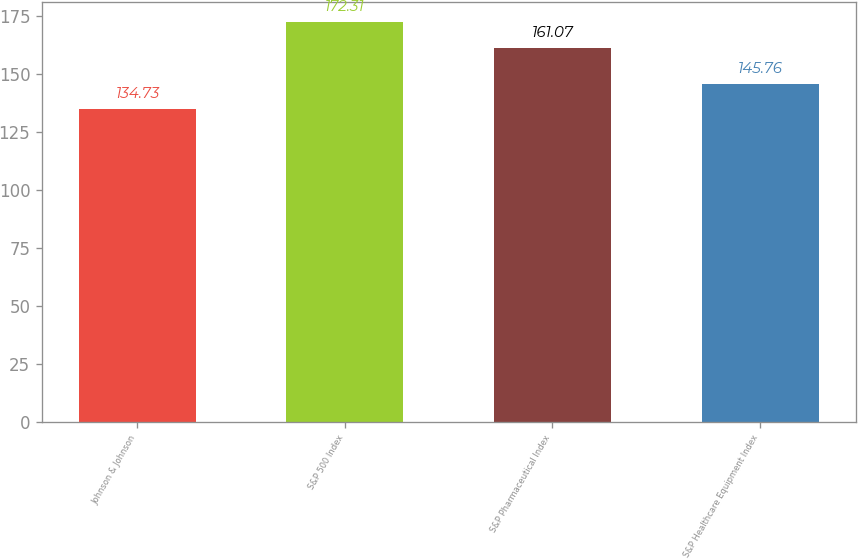Convert chart to OTSL. <chart><loc_0><loc_0><loc_500><loc_500><bar_chart><fcel>Johnson & Johnson<fcel>S&P 500 Index<fcel>S&P Pharmaceutical Index<fcel>S&P Healthcare Equipment Index<nl><fcel>134.73<fcel>172.31<fcel>161.07<fcel>145.76<nl></chart> 